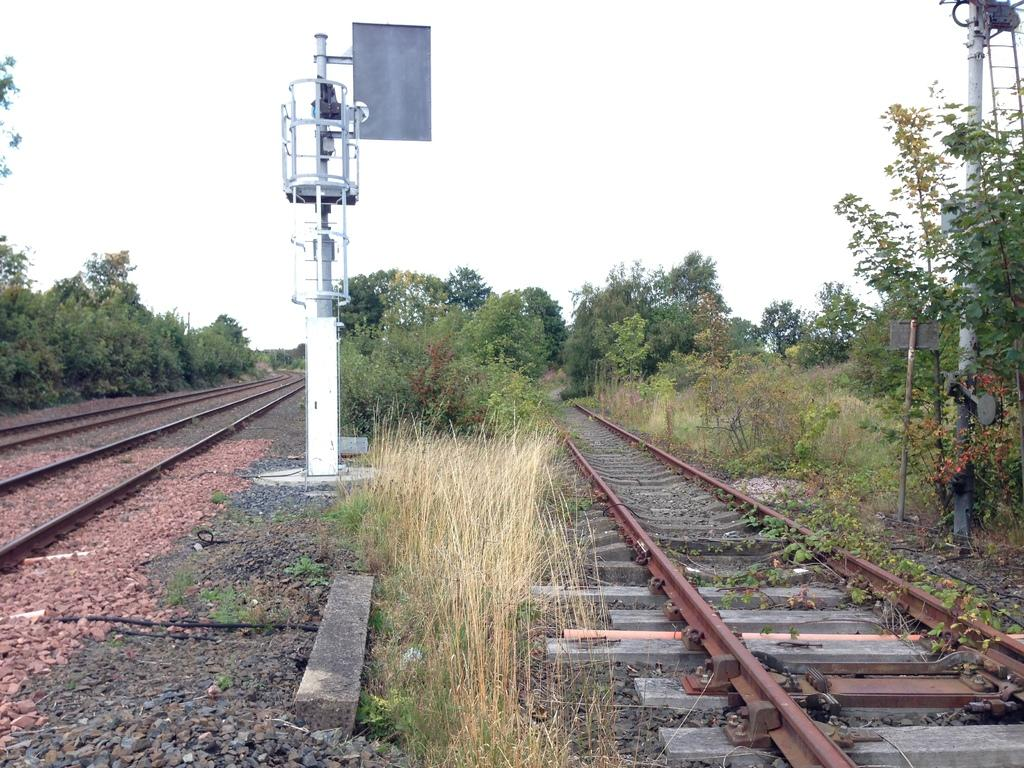What can be seen on the ground in the image? There are tracks and stones on the ground in the image. What is located in the middle of the image? There is a pole in the middle of the image, and it is white in color. What type of vegetation is visible in the image? There are trees and grass visible in the image. What is visible at the top of the image? The sky is visible at the top of the image. What type of pickle is hanging from the pole in the image? There is no pickle present in the image; the pole is white in color. What event is taking place in the image? There is no specific event depicted in the image; it shows tracks, stones, a pole, trees, grass, and the sky. 